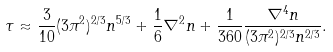Convert formula to latex. <formula><loc_0><loc_0><loc_500><loc_500>\tau \approx \frac { 3 } { 1 0 } ( 3 \pi ^ { 2 } ) ^ { 2 / 3 } n ^ { 5 / 3 } + \frac { 1 } { 6 } \nabla ^ { 2 } n + \frac { 1 } { 3 6 0 } \frac { \nabla ^ { 4 } n } { ( 3 \pi ^ { 2 } ) ^ { 2 / 3 } n ^ { 2 / 3 } } .</formula> 